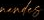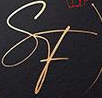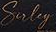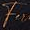Transcribe the words shown in these images in order, separated by a semicolon. #####; SF; Suley; Fu 